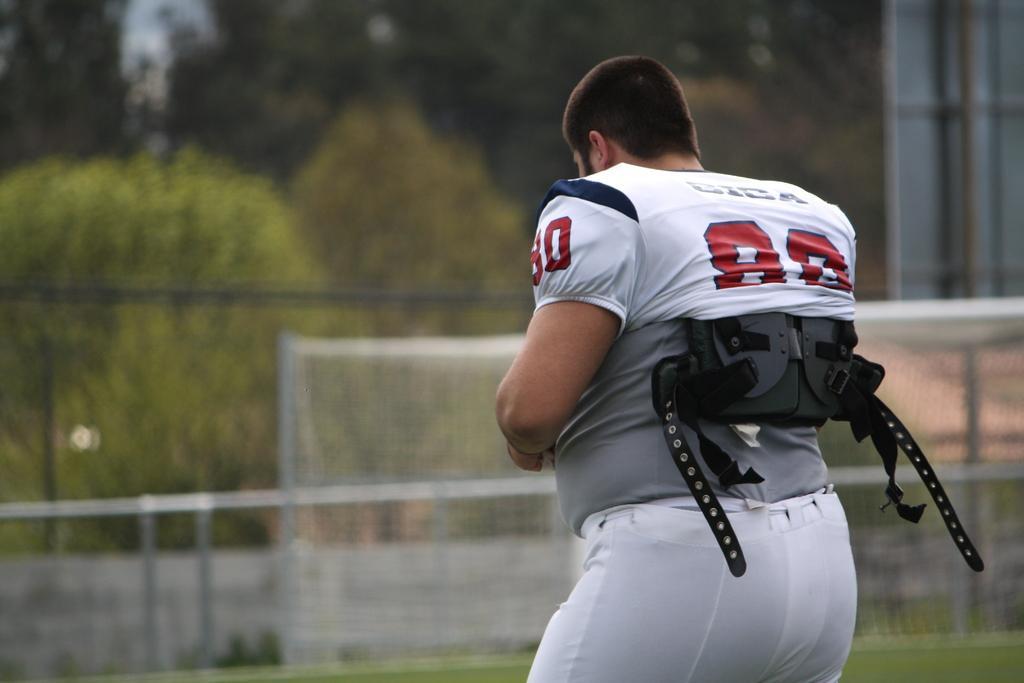Could you give a brief overview of what you see in this image? In the foreground of this image, there is a man wearing jacket. In the background, there is goal net, grass, railing, trees and a board. 